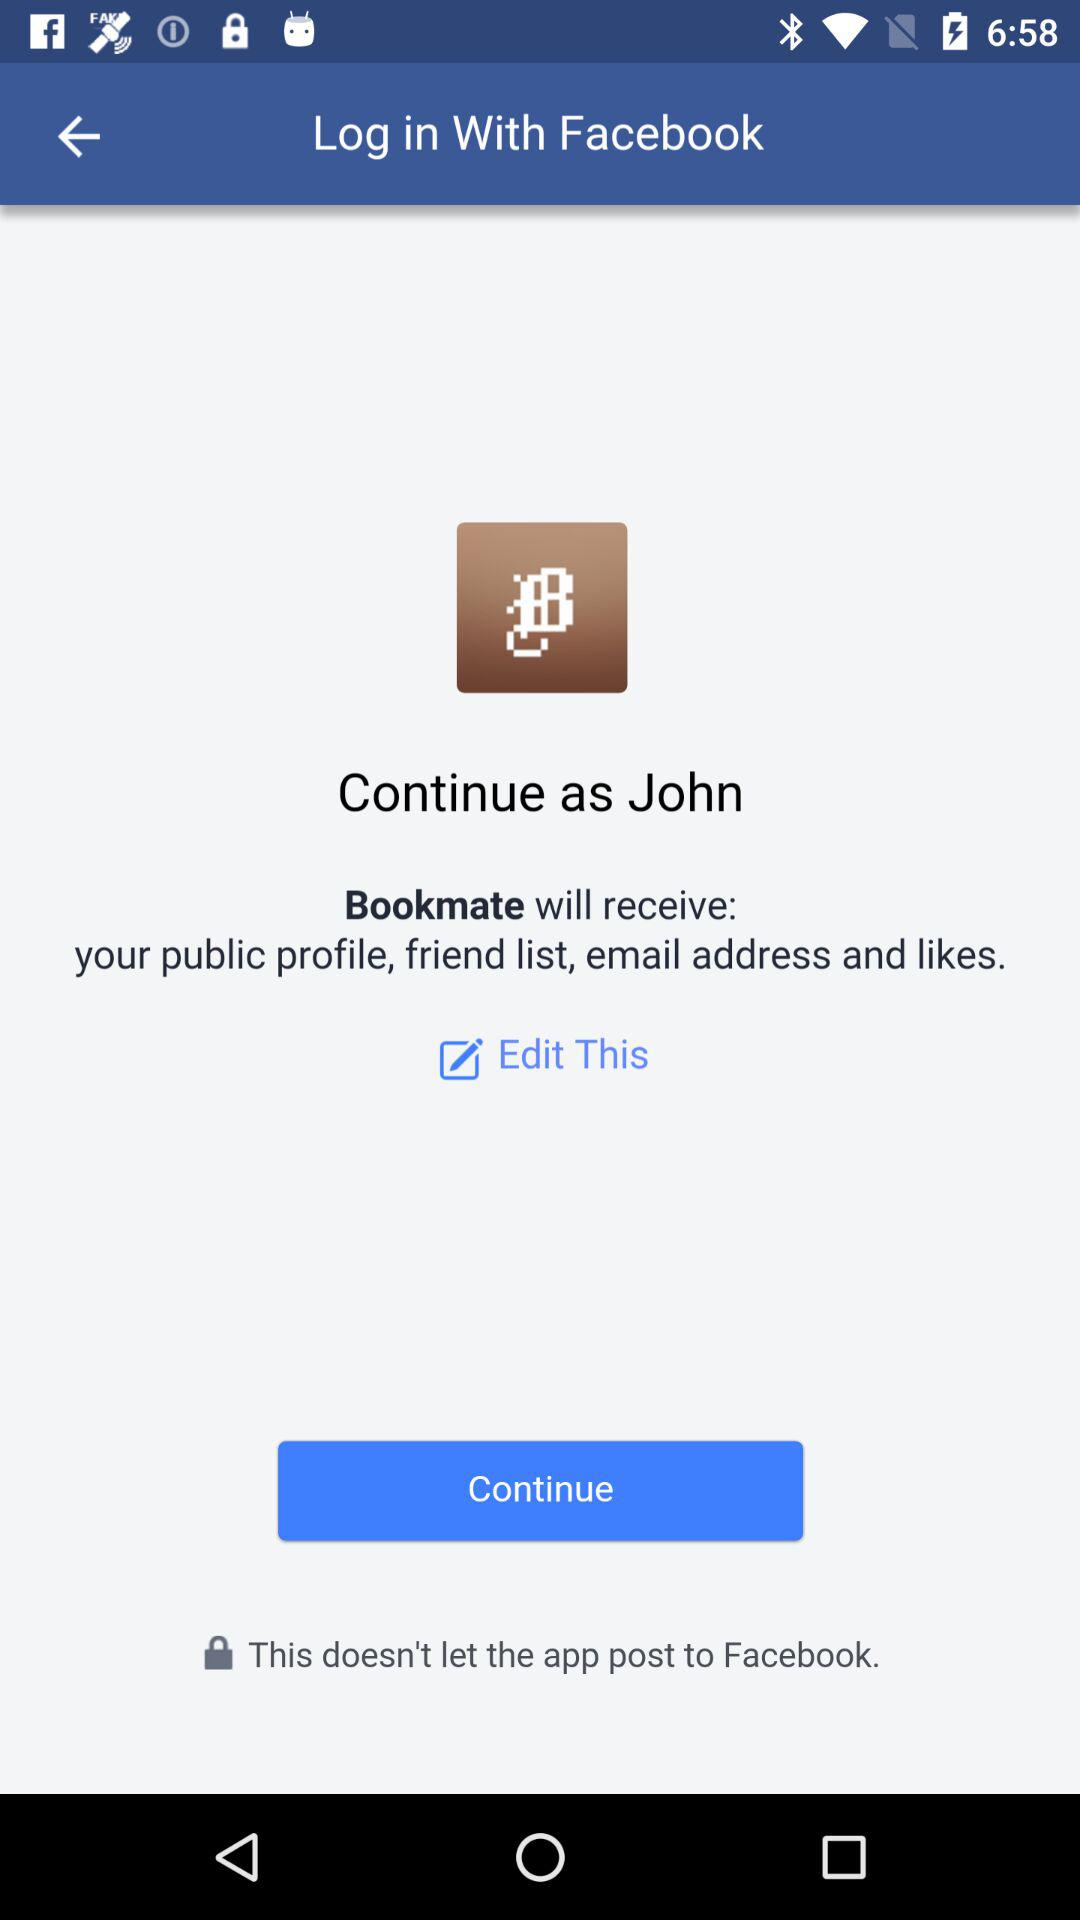Which application is asking for permission? The application asking for permission is "Bookmate". 